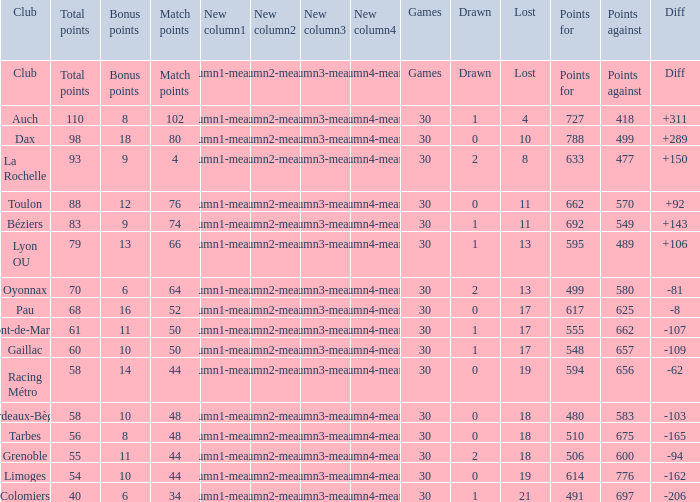What is the amount of match points for a club that lost 18 and has 11 bonus points? 44.0. 